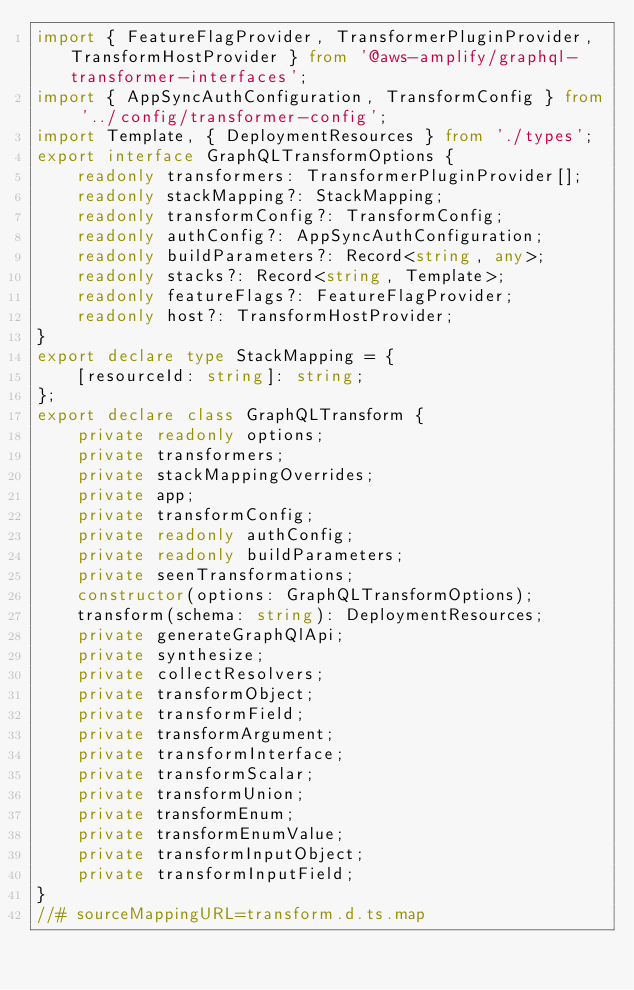Convert code to text. <code><loc_0><loc_0><loc_500><loc_500><_TypeScript_>import { FeatureFlagProvider, TransformerPluginProvider, TransformHostProvider } from '@aws-amplify/graphql-transformer-interfaces';
import { AppSyncAuthConfiguration, TransformConfig } from '../config/transformer-config';
import Template, { DeploymentResources } from './types';
export interface GraphQLTransformOptions {
    readonly transformers: TransformerPluginProvider[];
    readonly stackMapping?: StackMapping;
    readonly transformConfig?: TransformConfig;
    readonly authConfig?: AppSyncAuthConfiguration;
    readonly buildParameters?: Record<string, any>;
    readonly stacks?: Record<string, Template>;
    readonly featureFlags?: FeatureFlagProvider;
    readonly host?: TransformHostProvider;
}
export declare type StackMapping = {
    [resourceId: string]: string;
};
export declare class GraphQLTransform {
    private readonly options;
    private transformers;
    private stackMappingOverrides;
    private app;
    private transformConfig;
    private readonly authConfig;
    private readonly buildParameters;
    private seenTransformations;
    constructor(options: GraphQLTransformOptions);
    transform(schema: string): DeploymentResources;
    private generateGraphQlApi;
    private synthesize;
    private collectResolvers;
    private transformObject;
    private transformField;
    private transformArgument;
    private transformInterface;
    private transformScalar;
    private transformUnion;
    private transformEnum;
    private transformEnumValue;
    private transformInputObject;
    private transformInputField;
}
//# sourceMappingURL=transform.d.ts.map</code> 